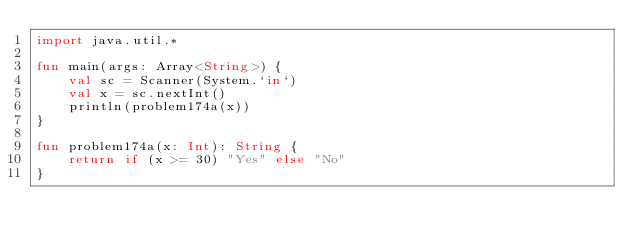Convert code to text. <code><loc_0><loc_0><loc_500><loc_500><_Kotlin_>import java.util.*

fun main(args: Array<String>) {
    val sc = Scanner(System.`in`)
    val x = sc.nextInt()
    println(problem174a(x))
}

fun problem174a(x: Int): String {
    return if (x >= 30) "Yes" else "No"
}</code> 